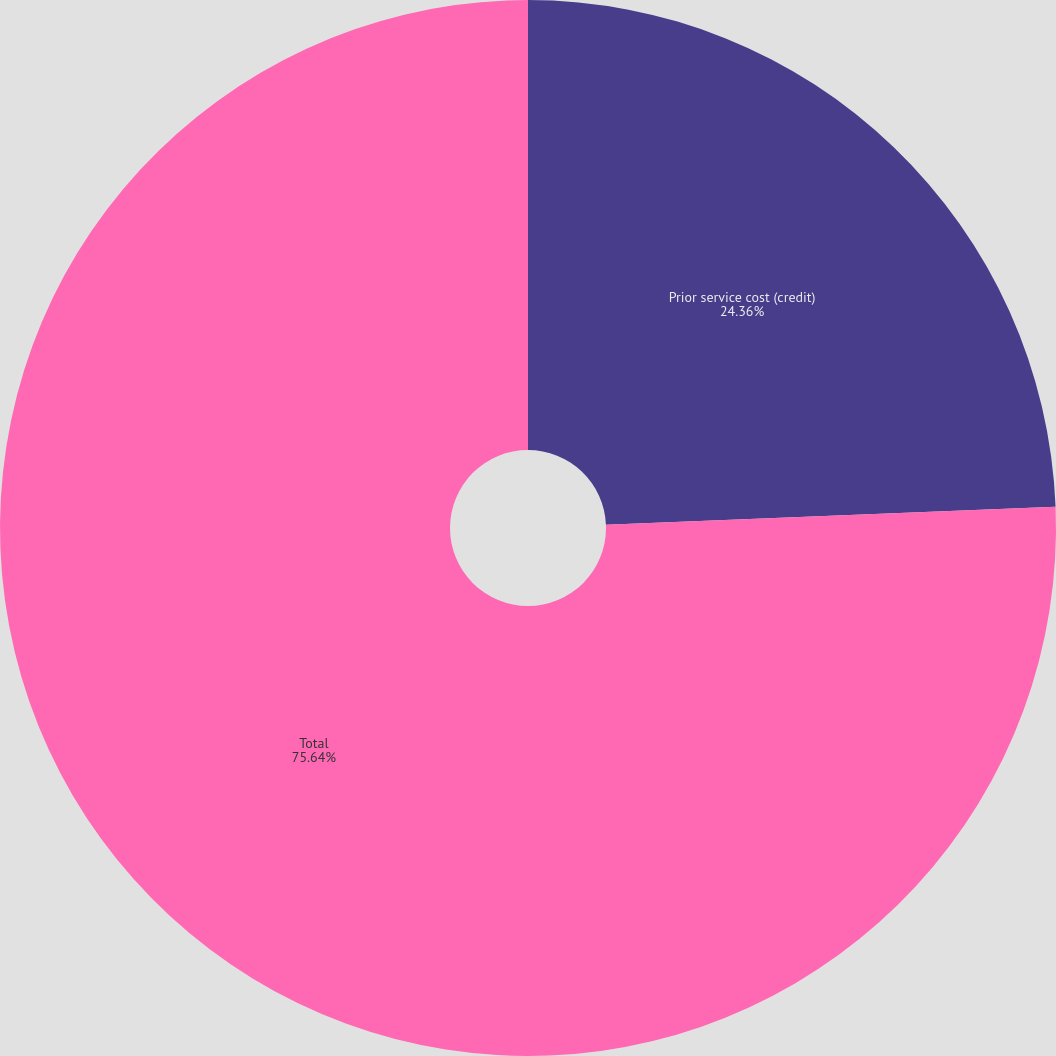Convert chart to OTSL. <chart><loc_0><loc_0><loc_500><loc_500><pie_chart><fcel>Prior service cost (credit)<fcel>Total<nl><fcel>24.36%<fcel>75.64%<nl></chart> 